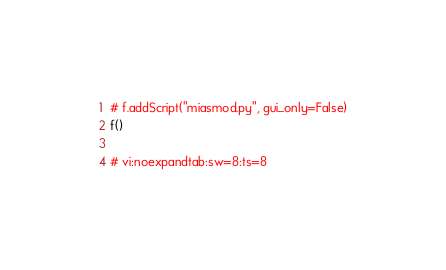Convert code to text. <code><loc_0><loc_0><loc_500><loc_500><_Python_># f.addScript("miasmod.py", gui_only=False)
f()

# vi:noexpandtab:sw=8:ts=8
</code> 